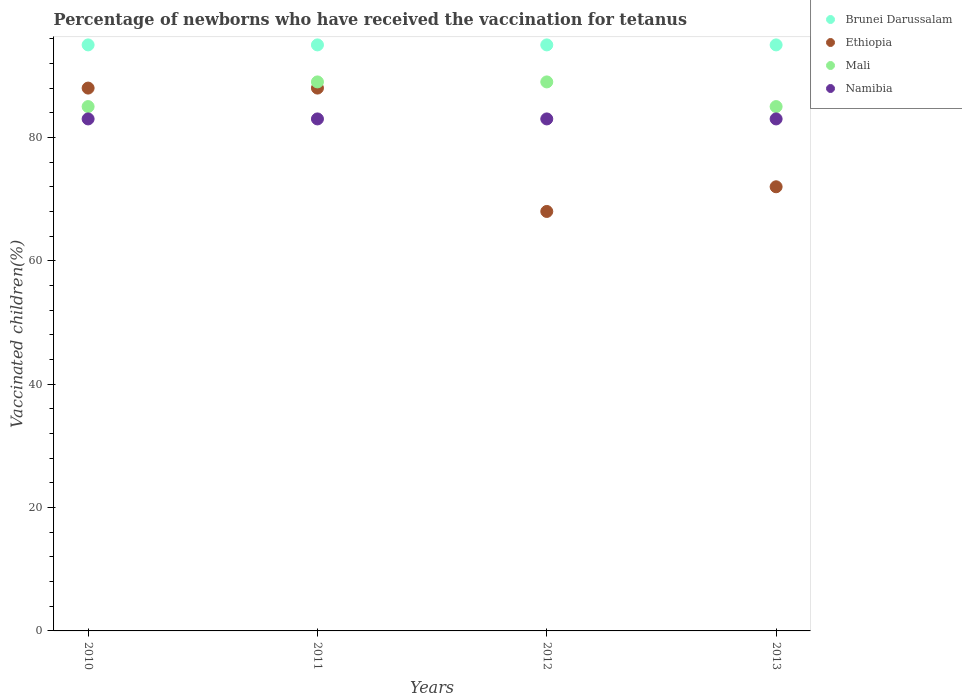How many different coloured dotlines are there?
Give a very brief answer. 4. Is the number of dotlines equal to the number of legend labels?
Keep it short and to the point. Yes. What is the percentage of vaccinated children in Mali in 2012?
Offer a very short reply. 89. Across all years, what is the maximum percentage of vaccinated children in Brunei Darussalam?
Your answer should be very brief. 95. Across all years, what is the minimum percentage of vaccinated children in Brunei Darussalam?
Provide a short and direct response. 95. In which year was the percentage of vaccinated children in Ethiopia maximum?
Provide a short and direct response. 2010. What is the total percentage of vaccinated children in Mali in the graph?
Your response must be concise. 348. What is the difference between the percentage of vaccinated children in Ethiopia in 2010 and that in 2013?
Offer a very short reply. 16. What is the difference between the percentage of vaccinated children in Mali in 2011 and the percentage of vaccinated children in Brunei Darussalam in 2012?
Your answer should be compact. -6. What is the average percentage of vaccinated children in Ethiopia per year?
Make the answer very short. 79. What is the ratio of the percentage of vaccinated children in Brunei Darussalam in 2010 to that in 2012?
Make the answer very short. 1. Is the difference between the percentage of vaccinated children in Brunei Darussalam in 2010 and 2012 greater than the difference between the percentage of vaccinated children in Mali in 2010 and 2012?
Provide a succinct answer. Yes. What is the difference between the highest and the second highest percentage of vaccinated children in Ethiopia?
Offer a very short reply. 0. Is the sum of the percentage of vaccinated children in Mali in 2010 and 2013 greater than the maximum percentage of vaccinated children in Ethiopia across all years?
Offer a very short reply. Yes. Is it the case that in every year, the sum of the percentage of vaccinated children in Brunei Darussalam and percentage of vaccinated children in Namibia  is greater than the percentage of vaccinated children in Mali?
Your response must be concise. Yes. Does the percentage of vaccinated children in Namibia monotonically increase over the years?
Offer a terse response. No. How many years are there in the graph?
Offer a terse response. 4. What is the difference between two consecutive major ticks on the Y-axis?
Ensure brevity in your answer.  20. Does the graph contain any zero values?
Give a very brief answer. No. Does the graph contain grids?
Your answer should be compact. No. Where does the legend appear in the graph?
Your response must be concise. Top right. How many legend labels are there?
Provide a succinct answer. 4. How are the legend labels stacked?
Make the answer very short. Vertical. What is the title of the graph?
Keep it short and to the point. Percentage of newborns who have received the vaccination for tetanus. Does "Mongolia" appear as one of the legend labels in the graph?
Offer a very short reply. No. What is the label or title of the Y-axis?
Your response must be concise. Vaccinated children(%). What is the Vaccinated children(%) of Namibia in 2010?
Make the answer very short. 83. What is the Vaccinated children(%) in Ethiopia in 2011?
Give a very brief answer. 88. What is the Vaccinated children(%) in Mali in 2011?
Give a very brief answer. 89. What is the Vaccinated children(%) of Mali in 2012?
Offer a very short reply. 89. What is the Vaccinated children(%) of Namibia in 2012?
Provide a succinct answer. 83. What is the Vaccinated children(%) of Ethiopia in 2013?
Offer a very short reply. 72. Across all years, what is the maximum Vaccinated children(%) in Brunei Darussalam?
Make the answer very short. 95. Across all years, what is the maximum Vaccinated children(%) in Ethiopia?
Provide a succinct answer. 88. Across all years, what is the maximum Vaccinated children(%) of Mali?
Your answer should be compact. 89. Across all years, what is the maximum Vaccinated children(%) in Namibia?
Keep it short and to the point. 83. Across all years, what is the minimum Vaccinated children(%) in Brunei Darussalam?
Ensure brevity in your answer.  95. Across all years, what is the minimum Vaccinated children(%) of Ethiopia?
Ensure brevity in your answer.  68. What is the total Vaccinated children(%) in Brunei Darussalam in the graph?
Give a very brief answer. 380. What is the total Vaccinated children(%) in Ethiopia in the graph?
Offer a very short reply. 316. What is the total Vaccinated children(%) in Mali in the graph?
Keep it short and to the point. 348. What is the total Vaccinated children(%) of Namibia in the graph?
Offer a very short reply. 332. What is the difference between the Vaccinated children(%) in Ethiopia in 2010 and that in 2011?
Provide a succinct answer. 0. What is the difference between the Vaccinated children(%) of Mali in 2010 and that in 2011?
Offer a terse response. -4. What is the difference between the Vaccinated children(%) in Namibia in 2010 and that in 2011?
Provide a short and direct response. 0. What is the difference between the Vaccinated children(%) in Brunei Darussalam in 2010 and that in 2012?
Ensure brevity in your answer.  0. What is the difference between the Vaccinated children(%) of Namibia in 2010 and that in 2012?
Ensure brevity in your answer.  0. What is the difference between the Vaccinated children(%) of Brunei Darussalam in 2010 and that in 2013?
Your answer should be compact. 0. What is the difference between the Vaccinated children(%) of Namibia in 2010 and that in 2013?
Give a very brief answer. 0. What is the difference between the Vaccinated children(%) of Brunei Darussalam in 2011 and that in 2012?
Offer a very short reply. 0. What is the difference between the Vaccinated children(%) of Ethiopia in 2011 and that in 2012?
Offer a terse response. 20. What is the difference between the Vaccinated children(%) of Mali in 2011 and that in 2012?
Your answer should be very brief. 0. What is the difference between the Vaccinated children(%) in Brunei Darussalam in 2011 and that in 2013?
Offer a terse response. 0. What is the difference between the Vaccinated children(%) of Mali in 2011 and that in 2013?
Your response must be concise. 4. What is the difference between the Vaccinated children(%) in Brunei Darussalam in 2012 and that in 2013?
Provide a short and direct response. 0. What is the difference between the Vaccinated children(%) of Mali in 2012 and that in 2013?
Give a very brief answer. 4. What is the difference between the Vaccinated children(%) of Brunei Darussalam in 2010 and the Vaccinated children(%) of Namibia in 2011?
Your answer should be compact. 12. What is the difference between the Vaccinated children(%) of Ethiopia in 2010 and the Vaccinated children(%) of Namibia in 2011?
Make the answer very short. 5. What is the difference between the Vaccinated children(%) of Mali in 2010 and the Vaccinated children(%) of Namibia in 2011?
Keep it short and to the point. 2. What is the difference between the Vaccinated children(%) of Brunei Darussalam in 2010 and the Vaccinated children(%) of Ethiopia in 2012?
Give a very brief answer. 27. What is the difference between the Vaccinated children(%) in Ethiopia in 2010 and the Vaccinated children(%) in Mali in 2012?
Your response must be concise. -1. What is the difference between the Vaccinated children(%) in Ethiopia in 2010 and the Vaccinated children(%) in Namibia in 2012?
Your response must be concise. 5. What is the difference between the Vaccinated children(%) of Brunei Darussalam in 2010 and the Vaccinated children(%) of Ethiopia in 2013?
Your answer should be very brief. 23. What is the difference between the Vaccinated children(%) of Brunei Darussalam in 2010 and the Vaccinated children(%) of Namibia in 2013?
Provide a short and direct response. 12. What is the difference between the Vaccinated children(%) in Ethiopia in 2010 and the Vaccinated children(%) in Mali in 2013?
Offer a very short reply. 3. What is the difference between the Vaccinated children(%) of Brunei Darussalam in 2011 and the Vaccinated children(%) of Ethiopia in 2012?
Ensure brevity in your answer.  27. What is the difference between the Vaccinated children(%) in Brunei Darussalam in 2011 and the Vaccinated children(%) in Namibia in 2012?
Provide a succinct answer. 12. What is the difference between the Vaccinated children(%) in Brunei Darussalam in 2011 and the Vaccinated children(%) in Mali in 2013?
Offer a very short reply. 10. What is the difference between the Vaccinated children(%) of Ethiopia in 2011 and the Vaccinated children(%) of Mali in 2013?
Offer a very short reply. 3. What is the difference between the Vaccinated children(%) of Mali in 2011 and the Vaccinated children(%) of Namibia in 2013?
Offer a very short reply. 6. What is the difference between the Vaccinated children(%) in Brunei Darussalam in 2012 and the Vaccinated children(%) in Ethiopia in 2013?
Provide a short and direct response. 23. What is the difference between the Vaccinated children(%) of Ethiopia in 2012 and the Vaccinated children(%) of Mali in 2013?
Your response must be concise. -17. What is the difference between the Vaccinated children(%) of Ethiopia in 2012 and the Vaccinated children(%) of Namibia in 2013?
Provide a short and direct response. -15. What is the average Vaccinated children(%) in Ethiopia per year?
Your response must be concise. 79. What is the average Vaccinated children(%) of Mali per year?
Make the answer very short. 87. In the year 2010, what is the difference between the Vaccinated children(%) in Brunei Darussalam and Vaccinated children(%) in Ethiopia?
Offer a very short reply. 7. In the year 2010, what is the difference between the Vaccinated children(%) of Ethiopia and Vaccinated children(%) of Mali?
Your answer should be compact. 3. In the year 2010, what is the difference between the Vaccinated children(%) of Ethiopia and Vaccinated children(%) of Namibia?
Ensure brevity in your answer.  5. In the year 2011, what is the difference between the Vaccinated children(%) in Brunei Darussalam and Vaccinated children(%) in Ethiopia?
Your answer should be compact. 7. In the year 2012, what is the difference between the Vaccinated children(%) in Ethiopia and Vaccinated children(%) in Mali?
Ensure brevity in your answer.  -21. In the year 2012, what is the difference between the Vaccinated children(%) of Ethiopia and Vaccinated children(%) of Namibia?
Give a very brief answer. -15. In the year 2013, what is the difference between the Vaccinated children(%) of Brunei Darussalam and Vaccinated children(%) of Ethiopia?
Offer a very short reply. 23. In the year 2013, what is the difference between the Vaccinated children(%) in Brunei Darussalam and Vaccinated children(%) in Namibia?
Keep it short and to the point. 12. In the year 2013, what is the difference between the Vaccinated children(%) of Ethiopia and Vaccinated children(%) of Mali?
Offer a very short reply. -13. In the year 2013, what is the difference between the Vaccinated children(%) in Mali and Vaccinated children(%) in Namibia?
Your response must be concise. 2. What is the ratio of the Vaccinated children(%) of Brunei Darussalam in 2010 to that in 2011?
Make the answer very short. 1. What is the ratio of the Vaccinated children(%) in Mali in 2010 to that in 2011?
Provide a short and direct response. 0.96. What is the ratio of the Vaccinated children(%) in Brunei Darussalam in 2010 to that in 2012?
Offer a terse response. 1. What is the ratio of the Vaccinated children(%) of Ethiopia in 2010 to that in 2012?
Ensure brevity in your answer.  1.29. What is the ratio of the Vaccinated children(%) of Mali in 2010 to that in 2012?
Your answer should be compact. 0.96. What is the ratio of the Vaccinated children(%) of Ethiopia in 2010 to that in 2013?
Provide a succinct answer. 1.22. What is the ratio of the Vaccinated children(%) of Mali in 2010 to that in 2013?
Give a very brief answer. 1. What is the ratio of the Vaccinated children(%) of Brunei Darussalam in 2011 to that in 2012?
Give a very brief answer. 1. What is the ratio of the Vaccinated children(%) in Ethiopia in 2011 to that in 2012?
Your response must be concise. 1.29. What is the ratio of the Vaccinated children(%) of Mali in 2011 to that in 2012?
Your answer should be very brief. 1. What is the ratio of the Vaccinated children(%) of Ethiopia in 2011 to that in 2013?
Ensure brevity in your answer.  1.22. What is the ratio of the Vaccinated children(%) of Mali in 2011 to that in 2013?
Provide a succinct answer. 1.05. What is the ratio of the Vaccinated children(%) in Ethiopia in 2012 to that in 2013?
Give a very brief answer. 0.94. What is the ratio of the Vaccinated children(%) in Mali in 2012 to that in 2013?
Make the answer very short. 1.05. What is the ratio of the Vaccinated children(%) in Namibia in 2012 to that in 2013?
Provide a succinct answer. 1. What is the difference between the highest and the second highest Vaccinated children(%) of Namibia?
Ensure brevity in your answer.  0. What is the difference between the highest and the lowest Vaccinated children(%) of Mali?
Offer a very short reply. 4. What is the difference between the highest and the lowest Vaccinated children(%) in Namibia?
Provide a short and direct response. 0. 